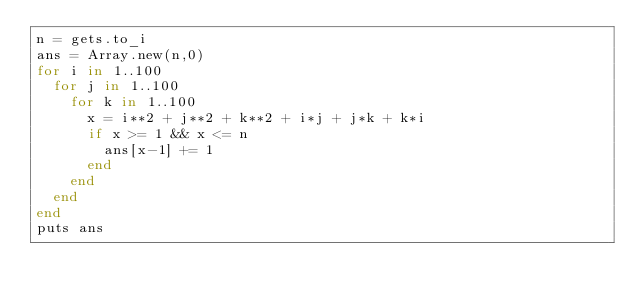<code> <loc_0><loc_0><loc_500><loc_500><_Ruby_>n = gets.to_i
ans = Array.new(n,0)
for i in 1..100
  for j in 1..100
    for k in 1..100
      x = i**2 + j**2 + k**2 + i*j + j*k + k*i
      if x >= 1 && x <= n
        ans[x-1] += 1
      end
    end
  end
end
puts ans</code> 